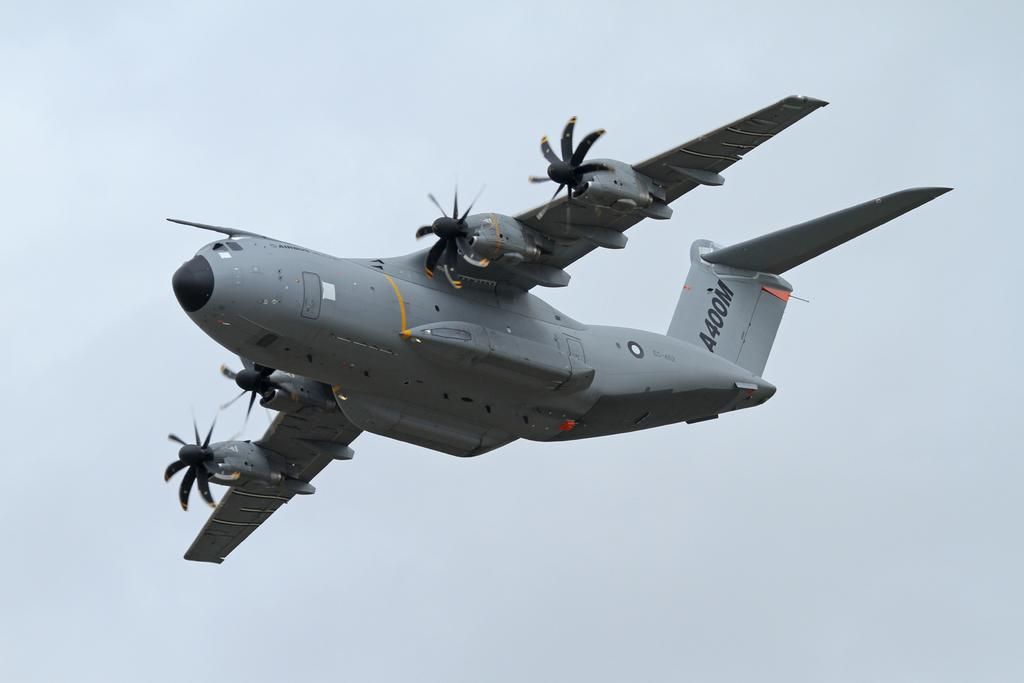What is the main subject of the image? The main subject of the image is an aircraft. What is the aircraft doing in the image? The aircraft is flying in the air. What can be seen in the background of the image? The sky is visible in the background of the image. What type of prose is being recited by the aircraft in the image? There is no indication in the image that the aircraft is reciting any prose. 